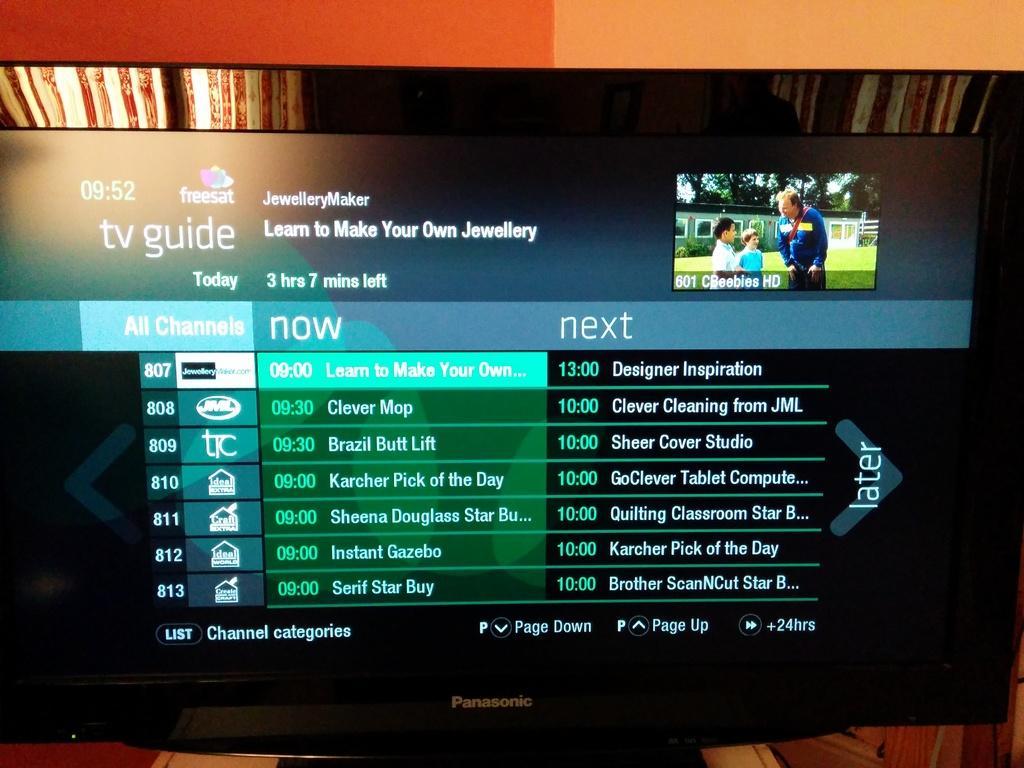Could you give a brief overview of what you see in this image? In this image there is a screen. On the screen in the top right there is a picture of a man with two kids. There are few text here. In the background there is curtain. 